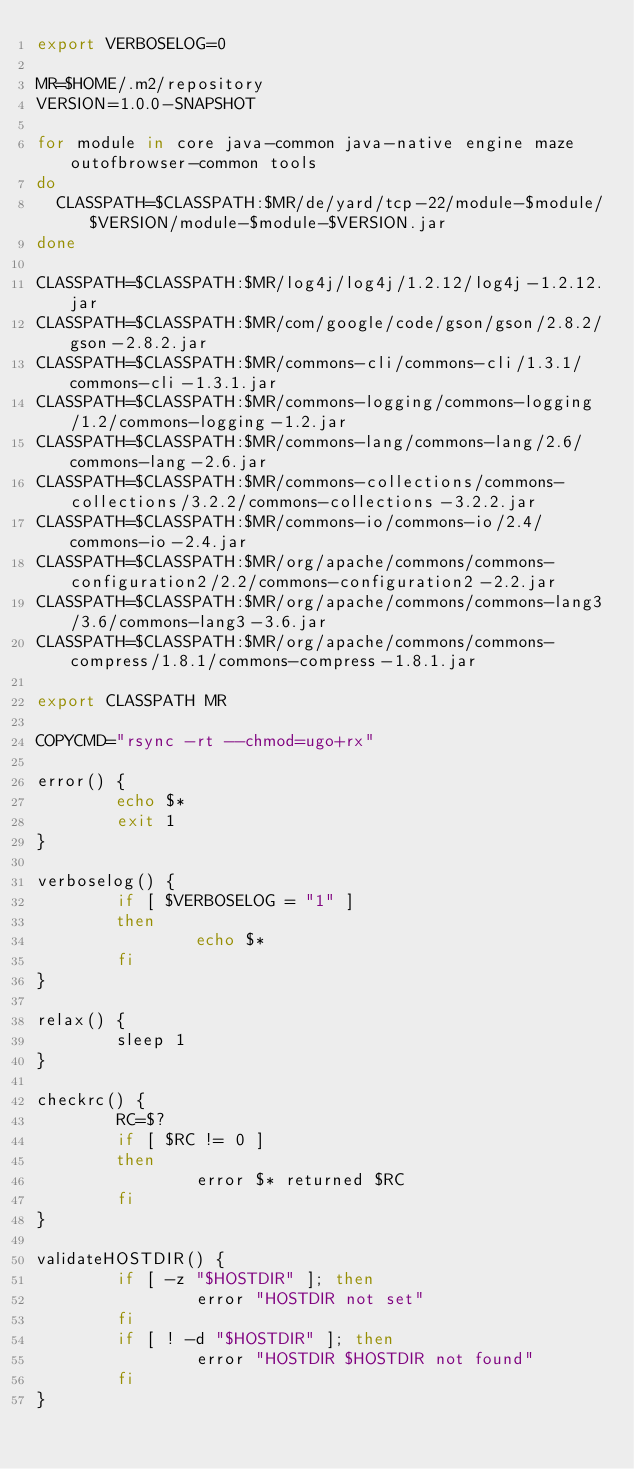Convert code to text. <code><loc_0><loc_0><loc_500><loc_500><_Bash_>export VERBOSELOG=0

MR=$HOME/.m2/repository
VERSION=1.0.0-SNAPSHOT

for module in core java-common java-native engine maze outofbrowser-common tools
do
  CLASSPATH=$CLASSPATH:$MR/de/yard/tcp-22/module-$module/$VERSION/module-$module-$VERSION.jar
done

CLASSPATH=$CLASSPATH:$MR/log4j/log4j/1.2.12/log4j-1.2.12.jar
CLASSPATH=$CLASSPATH:$MR/com/google/code/gson/gson/2.8.2/gson-2.8.2.jar
CLASSPATH=$CLASSPATH:$MR/commons-cli/commons-cli/1.3.1/commons-cli-1.3.1.jar
CLASSPATH=$CLASSPATH:$MR/commons-logging/commons-logging/1.2/commons-logging-1.2.jar
CLASSPATH=$CLASSPATH:$MR/commons-lang/commons-lang/2.6/commons-lang-2.6.jar
CLASSPATH=$CLASSPATH:$MR/commons-collections/commons-collections/3.2.2/commons-collections-3.2.2.jar
CLASSPATH=$CLASSPATH:$MR/commons-io/commons-io/2.4/commons-io-2.4.jar
CLASSPATH=$CLASSPATH:$MR/org/apache/commons/commons-configuration2/2.2/commons-configuration2-2.2.jar
CLASSPATH=$CLASSPATH:$MR/org/apache/commons/commons-lang3/3.6/commons-lang3-3.6.jar
CLASSPATH=$CLASSPATH:$MR/org/apache/commons/commons-compress/1.8.1/commons-compress-1.8.1.jar

export CLASSPATH MR

COPYCMD="rsync -rt --chmod=ugo+rx"

error() {
        echo $*
        exit 1
}

verboselog() {
        if [ $VERBOSELOG = "1" ]
        then
                echo $*
        fi
}

relax() {
        sleep 1
}

checkrc() {
        RC=$?
        if [ $RC != 0 ]
        then
                error $* returned $RC
        fi
}

validateHOSTDIR() {
        if [ -z "$HOSTDIR" ]; then
                error "HOSTDIR not set"
        fi
        if [ ! -d "$HOSTDIR" ]; then
                error "HOSTDIR $HOSTDIR not found"
        fi
}</code> 